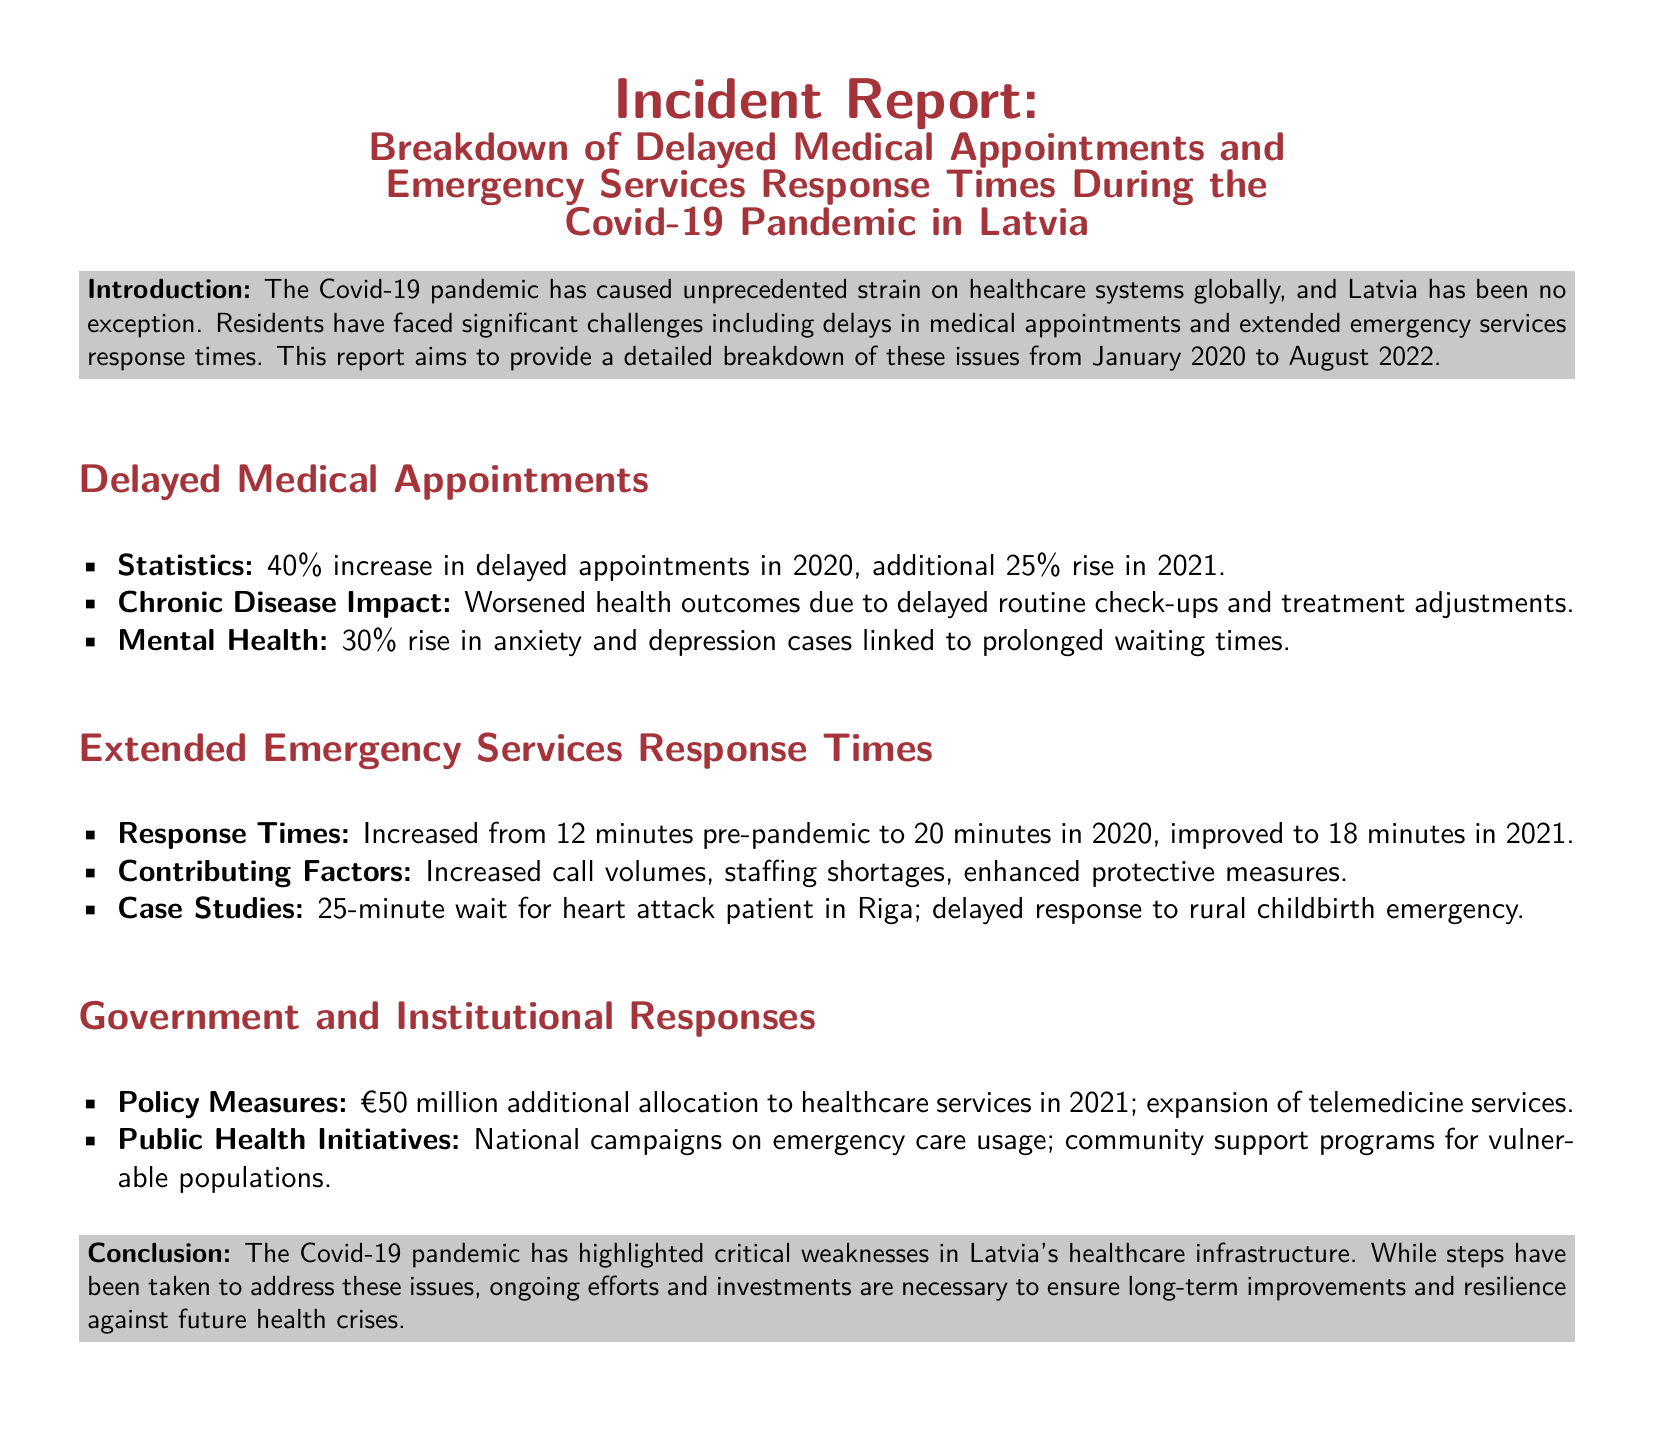What was the percentage increase in delayed appointments in 2020? The document states there was a 40% increase in delayed appointments in 2020.
Answer: 40% What was the average emergency response time in 2020? According to the report, the average response time increased to 20 minutes in 2020.
Answer: 20 minutes What was the additional funding allocated to healthcare services in 2021? The report mentions a €50 million allocation to healthcare services in 2021.
Answer: €50 million How much did anxiety and depression cases rise due to delayed appointments? The document indicates a 30% rise in anxiety and depression cases linked to prolonged waiting times.
Answer: 30% What was the improved average emergency response time in 2021? The report states that the average response time improved to 18 minutes in 2021.
Answer: 18 minutes What significant health issues were highlighted due to delays in medical appointments? The report notes that there were worsened health outcomes due to delayed routine check-ups and treatment adjustments.
Answer: Worsened health outcomes What were some contributing factors to the extended emergency services response times? The document lists increased call volumes, staffing shortages, and enhanced protective measures as contributing factors.
Answer: Increased call volumes, staffing shortages, enhanced protective measures Which system was expanded as part of the government's response? The report highlights the expansion of telemedicine services as a response measure.
Answer: Telemedicine services What emergency case was specifically noted in Riga? The document mentions a 25-minute wait for a heart attack patient in Riga.
Answer: 25-minute wait for heart attack patient 